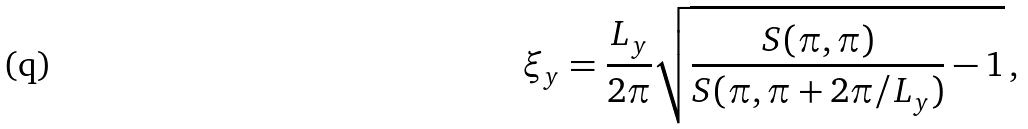<formula> <loc_0><loc_0><loc_500><loc_500>\xi _ { y } = \frac { L _ { y } } { 2 \pi } \sqrt { \frac { S ( \pi , \pi ) } { S ( \pi , \pi + 2 \pi / L _ { y } ) } - 1 } \, ,</formula> 